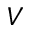<formula> <loc_0><loc_0><loc_500><loc_500>V</formula> 